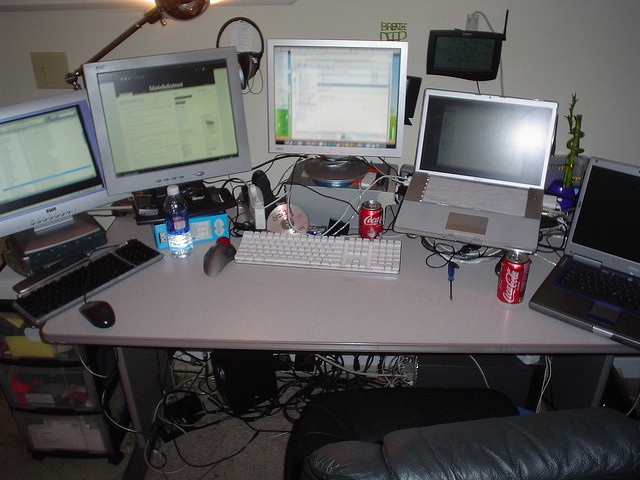Describe the objects in this image and their specific colors. I can see laptop in gray, lightgray, and black tones, tv in gray, darkgray, and black tones, tv in gray, lightgray, and darkgray tones, laptop in gray, black, and darkblue tones, and tv in gray, darkgray, and black tones in this image. 